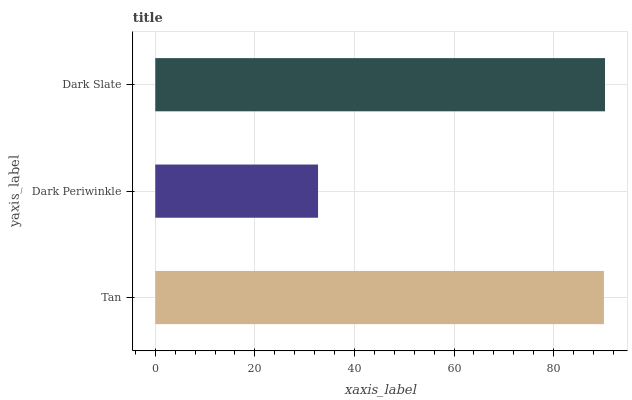Is Dark Periwinkle the minimum?
Answer yes or no. Yes. Is Dark Slate the maximum?
Answer yes or no. Yes. Is Dark Slate the minimum?
Answer yes or no. No. Is Dark Periwinkle the maximum?
Answer yes or no. No. Is Dark Slate greater than Dark Periwinkle?
Answer yes or no. Yes. Is Dark Periwinkle less than Dark Slate?
Answer yes or no. Yes. Is Dark Periwinkle greater than Dark Slate?
Answer yes or no. No. Is Dark Slate less than Dark Periwinkle?
Answer yes or no. No. Is Tan the high median?
Answer yes or no. Yes. Is Tan the low median?
Answer yes or no. Yes. Is Dark Slate the high median?
Answer yes or no. No. Is Dark Periwinkle the low median?
Answer yes or no. No. 